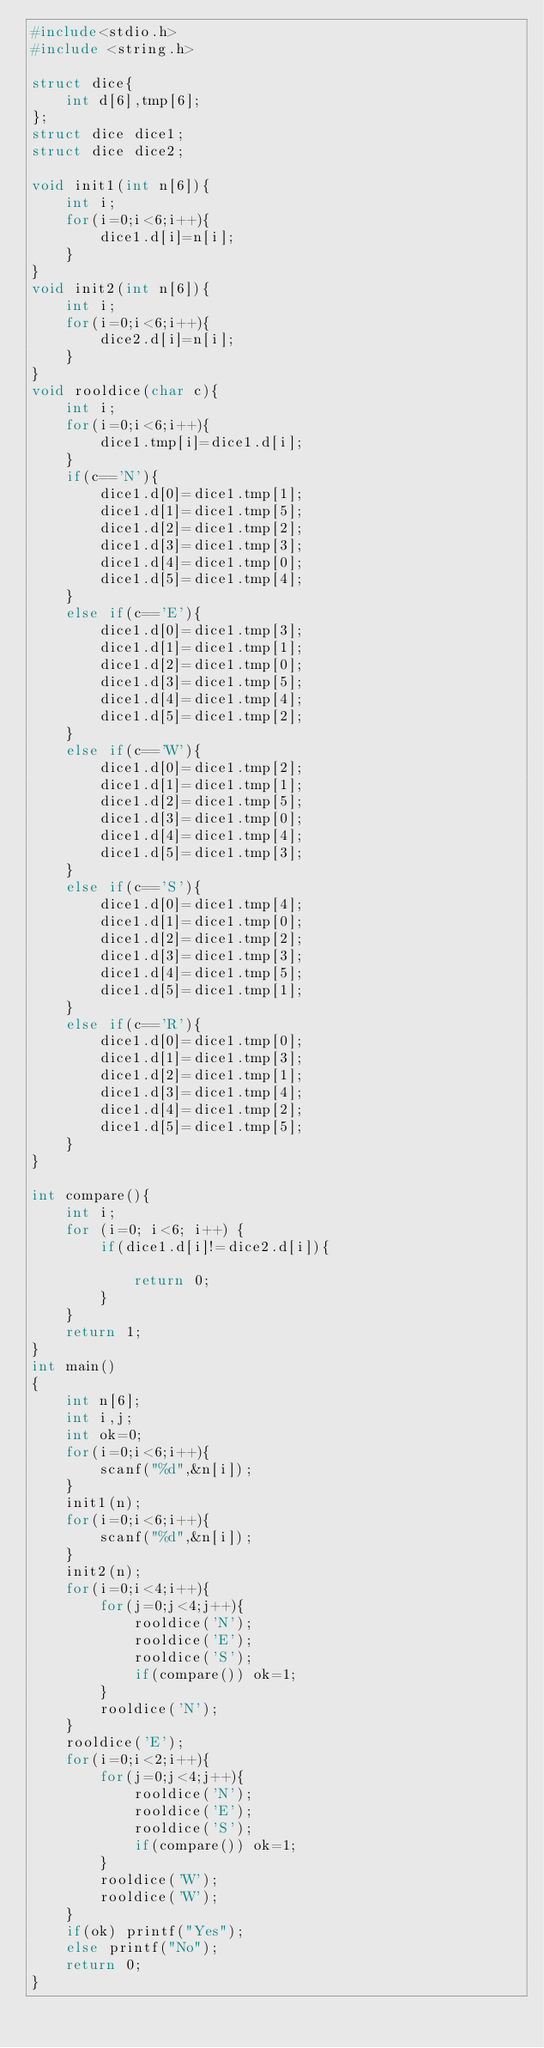Convert code to text. <code><loc_0><loc_0><loc_500><loc_500><_C_>#include<stdio.h>
#include <string.h>

struct dice{
    int d[6],tmp[6];
};
struct dice dice1;
struct dice dice2;

void init1(int n[6]){
    int i;
    for(i=0;i<6;i++){
        dice1.d[i]=n[i];
    }
}
void init2(int n[6]){
    int i;
    for(i=0;i<6;i++){
        dice2.d[i]=n[i];
    }
}
void rooldice(char c){
    int i;
    for(i=0;i<6;i++){
        dice1.tmp[i]=dice1.d[i];
    }
    if(c=='N'){
        dice1.d[0]=dice1.tmp[1];
        dice1.d[1]=dice1.tmp[5];
        dice1.d[2]=dice1.tmp[2];
        dice1.d[3]=dice1.tmp[3];
        dice1.d[4]=dice1.tmp[0];
        dice1.d[5]=dice1.tmp[4];
    }
    else if(c=='E'){
        dice1.d[0]=dice1.tmp[3];
        dice1.d[1]=dice1.tmp[1];
        dice1.d[2]=dice1.tmp[0];
        dice1.d[3]=dice1.tmp[5];
        dice1.d[4]=dice1.tmp[4];
        dice1.d[5]=dice1.tmp[2];
    }
    else if(c=='W'){
        dice1.d[0]=dice1.tmp[2];
        dice1.d[1]=dice1.tmp[1];
        dice1.d[2]=dice1.tmp[5];
        dice1.d[3]=dice1.tmp[0];
        dice1.d[4]=dice1.tmp[4];
        dice1.d[5]=dice1.tmp[3];
    }
    else if(c=='S'){
        dice1.d[0]=dice1.tmp[4];
        dice1.d[1]=dice1.tmp[0];
        dice1.d[2]=dice1.tmp[2];
        dice1.d[3]=dice1.tmp[3];
        dice1.d[4]=dice1.tmp[5];
        dice1.d[5]=dice1.tmp[1];
    }
    else if(c=='R'){
        dice1.d[0]=dice1.tmp[0];
        dice1.d[1]=dice1.tmp[3];
        dice1.d[2]=dice1.tmp[1];
        dice1.d[3]=dice1.tmp[4];
        dice1.d[4]=dice1.tmp[2];
        dice1.d[5]=dice1.tmp[5];
    }
}

int compare(){
    int i;
    for (i=0; i<6; i++) {
        if(dice1.d[i]!=dice2.d[i]){
    
            return 0;
        }
    }
    return 1;
}
int main()
{
    int n[6];
    int i,j;
    int ok=0;
    for(i=0;i<6;i++){
        scanf("%d",&n[i]);
    }
    init1(n);
    for(i=0;i<6;i++){
        scanf("%d",&n[i]);
    }
    init2(n);
    for(i=0;i<4;i++){
        for(j=0;j<4;j++){
            rooldice('N');
            rooldice('E');
            rooldice('S');
            if(compare()) ok=1;
        }
        rooldice('N');
    }
    rooldice('E');
    for(i=0;i<2;i++){
        for(j=0;j<4;j++){
            rooldice('N');
            rooldice('E');
            rooldice('S');
            if(compare()) ok=1;
        }
        rooldice('W');
        rooldice('W');
    }
    if(ok) printf("Yes");
    else printf("No");
    return 0;
}</code> 